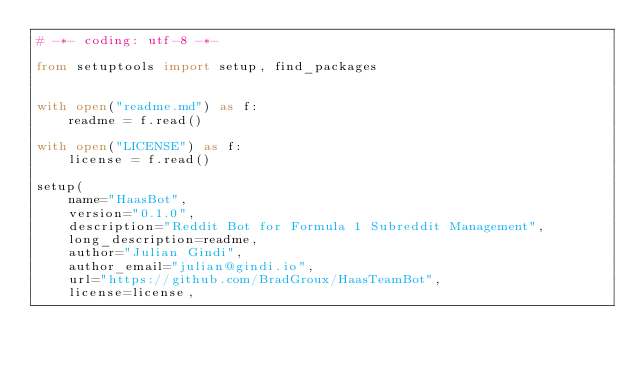Convert code to text. <code><loc_0><loc_0><loc_500><loc_500><_Python_># -*- coding: utf-8 -*-

from setuptools import setup, find_packages


with open("readme.md") as f:
    readme = f.read()

with open("LICENSE") as f:
    license = f.read()

setup(
    name="HaasBot",
    version="0.1.0",
    description="Reddit Bot for Formula 1 Subreddit Management",
    long_description=readme,
    author="Julian Gindi",
    author_email="julian@gindi.io",
    url="https://github.com/BradGroux/HaasTeamBot",
    license=license,</code> 